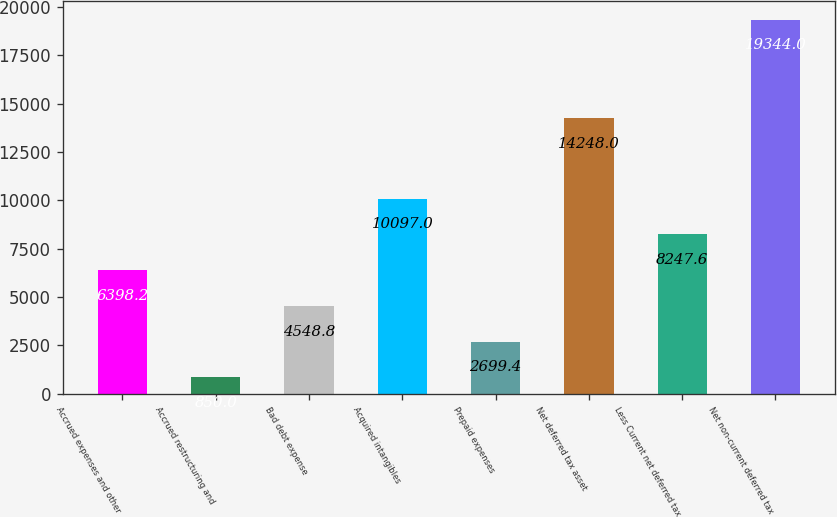<chart> <loc_0><loc_0><loc_500><loc_500><bar_chart><fcel>Accrued expenses and other<fcel>Accrued restructuring and<fcel>Bad debt expense<fcel>Acquired intangibles<fcel>Prepaid expenses<fcel>Net deferred tax asset<fcel>Less Current net deferred tax<fcel>Net non-current deferred tax<nl><fcel>6398.2<fcel>850<fcel>4548.8<fcel>10097<fcel>2699.4<fcel>14248<fcel>8247.6<fcel>19344<nl></chart> 